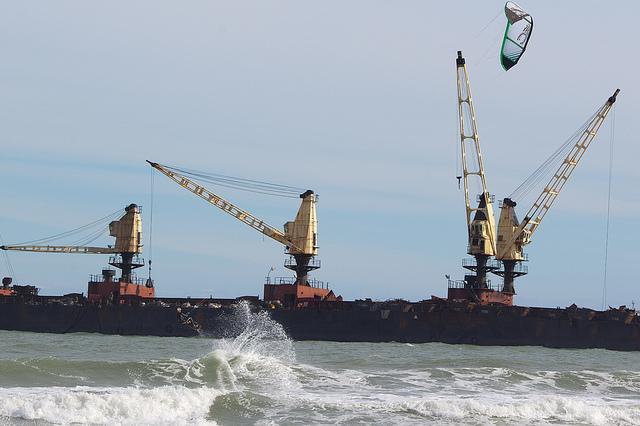How many couches have a blue pillow?
Give a very brief answer. 0. 